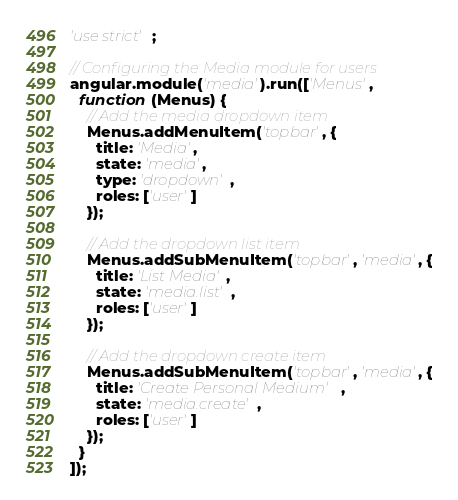<code> <loc_0><loc_0><loc_500><loc_500><_JavaScript_>'use strict';

// Configuring the Media module for users
angular.module('media').run(['Menus',
  function (Menus) {
    // Add the media dropdown item
    Menus.addMenuItem('topbar', {
      title: 'Media',
      state: 'media',
      type: 'dropdown',
      roles: ['user']
    });

    // Add the dropdown list item
    Menus.addSubMenuItem('topbar', 'media', {
      title: 'List Media',
      state: 'media.list',
      roles: ['user']
    });

    // Add the dropdown create item
    Menus.addSubMenuItem('topbar', 'media', {
      title: 'Create Personal Medium',
      state: 'media.create',
      roles: ['user']
    });
  }
]);
</code> 